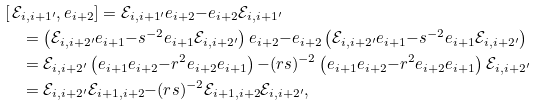Convert formula to latex. <formula><loc_0><loc_0><loc_500><loc_500>& [ \, \mathcal { E } _ { i , i + 1 ^ { \prime } } , e _ { i + 2 } ] = \mathcal { E } _ { i , i + 1 ^ { \prime } } e _ { i + 2 } { - } e _ { i + 2 } \mathcal { E } _ { i , i + 1 ^ { \prime } } \\ & \quad = \left ( \mathcal { E } _ { i , i + 2 ^ { \prime } } e _ { i + 1 } { - } s ^ { - 2 } e _ { i + 1 } \mathcal { E } _ { i , i + 2 ^ { \prime } } \right ) e _ { i + 2 } { - } e _ { i + 2 } \left ( \mathcal { E } _ { i , i + 2 ^ { \prime } } e _ { i + 1 } { - } s ^ { - 2 } e _ { i + 1 } \mathcal { E } _ { i , i + 2 ^ { \prime } } \right ) \\ & \quad = \mathcal { E } _ { i , i + 2 ^ { \prime } } \left ( e _ { i + 1 } e _ { i + 2 } { - } r ^ { 2 } e _ { i + 2 } e _ { i + 1 } \right ) { - } ( r s ) ^ { - 2 } \left ( e _ { i + 1 } e _ { i + 2 } { - } r ^ { 2 } e _ { i + 2 } e _ { i + 1 } \right ) \mathcal { E } _ { i , i + 2 ^ { \prime } } \\ & \quad = \mathcal { E } _ { i , i + 2 ^ { \prime } } \mathcal { E } _ { i + 1 , i + 2 } { - } ( r s ) ^ { - 2 } \mathcal { E } _ { i + 1 , i + 2 } \mathcal { E } _ { i , i + 2 ^ { \prime } } ,</formula> 